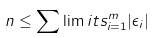<formula> <loc_0><loc_0><loc_500><loc_500>n \leq \sum \lim i t s _ { i = 1 } ^ { m } | \epsilon _ { i } |</formula> 